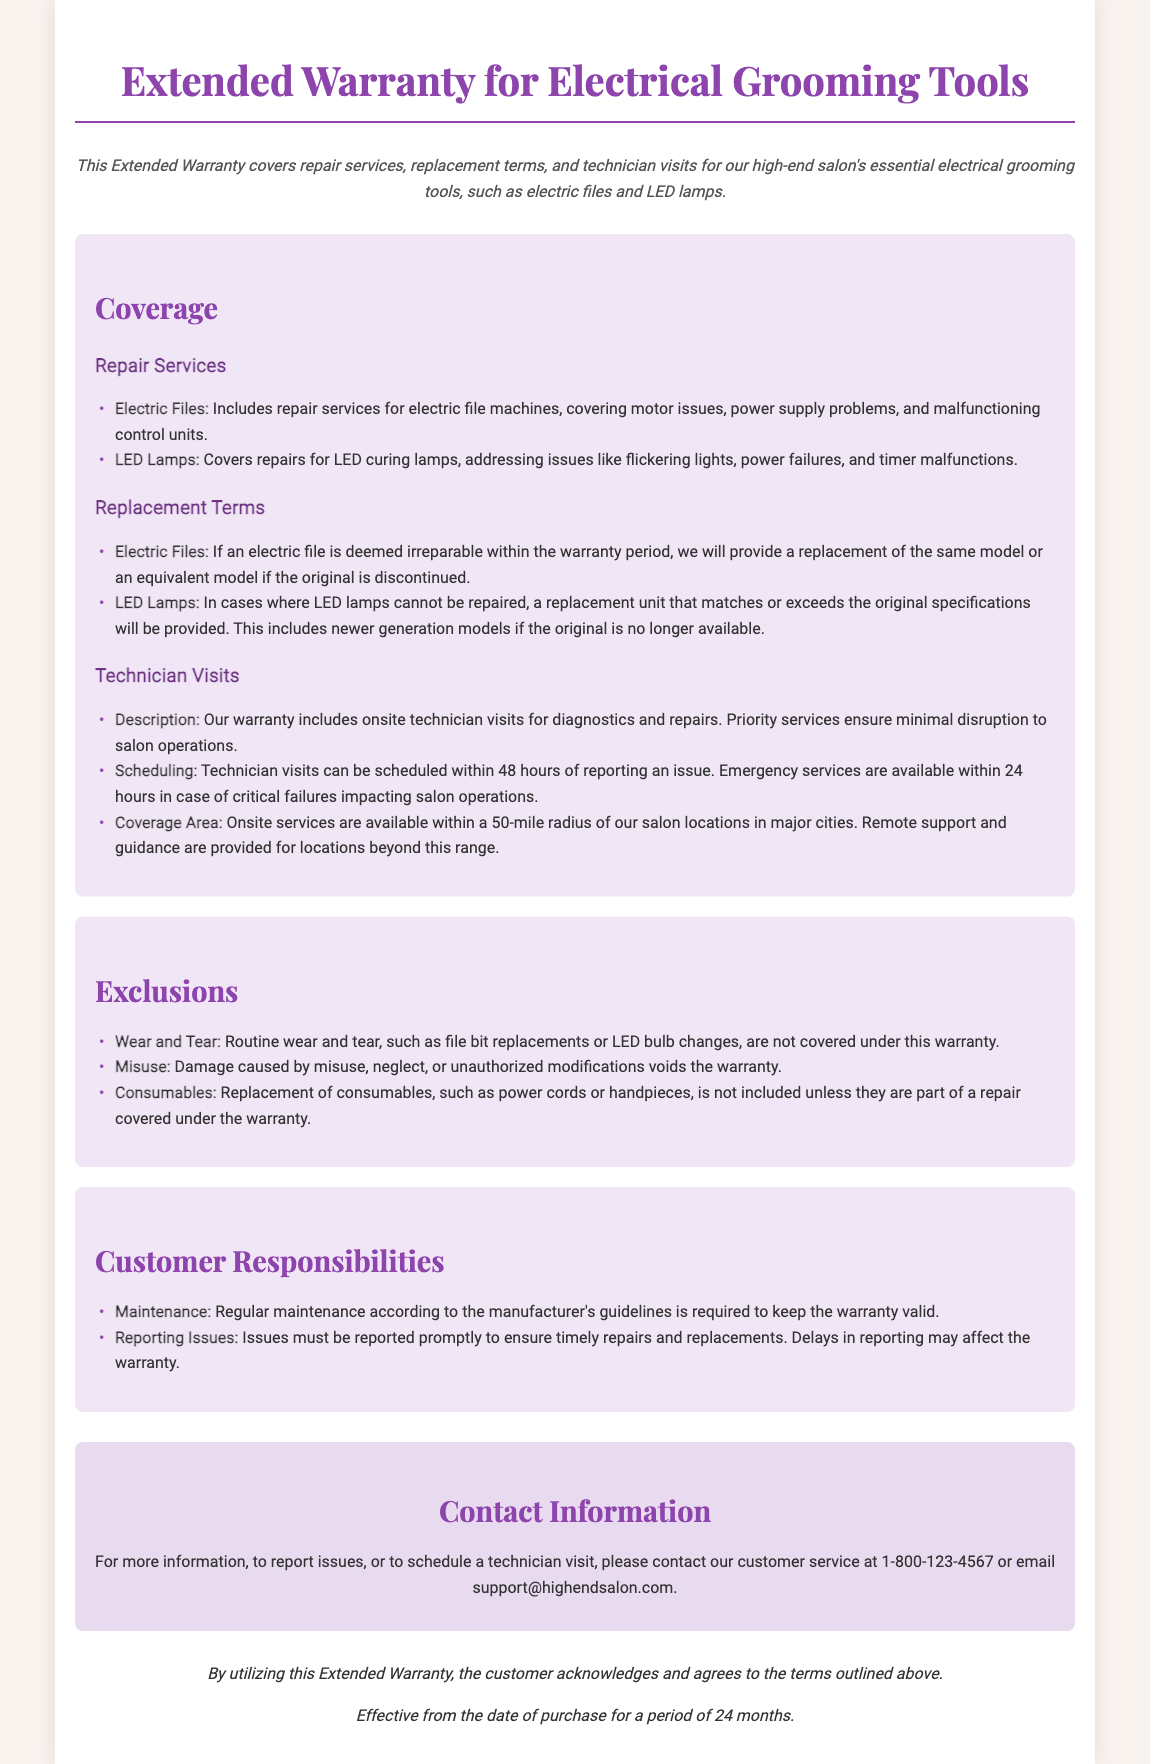What tools does the warranty cover? The warranty covers electrical grooming tools, specifically electric files and LED lamps.
Answer: electric files and LED lamps What is the replacement term for an irreparable electric file? The warranty states that if an electric file is deemed irreparable, a replacement of the same model or an equivalent model will be provided.
Answer: same model or equivalent model What is the maximum time for scheduling technician visits? Technician visits can be scheduled within 48 hours of reporting an issue as per the warranty details.
Answer: 48 hours What is excluded from the warranty coverage? The document specifies exclusions such as routine wear and tear, misuse, and consumables.
Answer: routine wear and tear, misuse, and consumables What is required for warranty validity regarding maintenance? The warranty requires regular maintenance according to the manufacturer's guidelines to remain valid.
Answer: regular maintenance How quickly can emergency services be provided? In case of critical failures impacting salon operations, emergency services are available within 24 hours of reporting.
Answer: 24 hours 